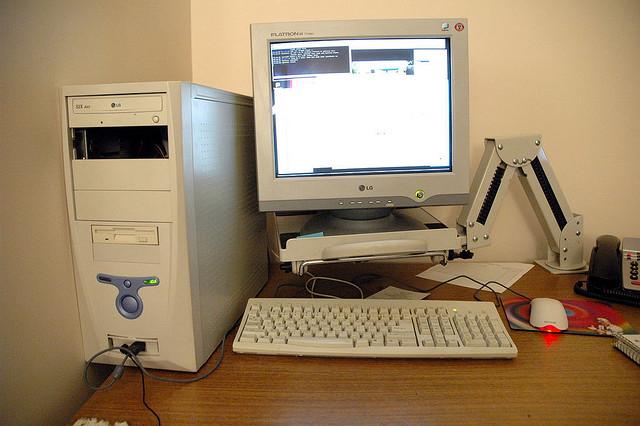Is the mouse wireless?
Be succinct. No. What brand of computer is this?
Give a very brief answer. Lg. What brand is the computer?
Concise answer only. Lg. What color is the light that is on the bottom of the mouse?
Short answer required. Red. Is the an updated desktop computer?
Quick response, please. No. 